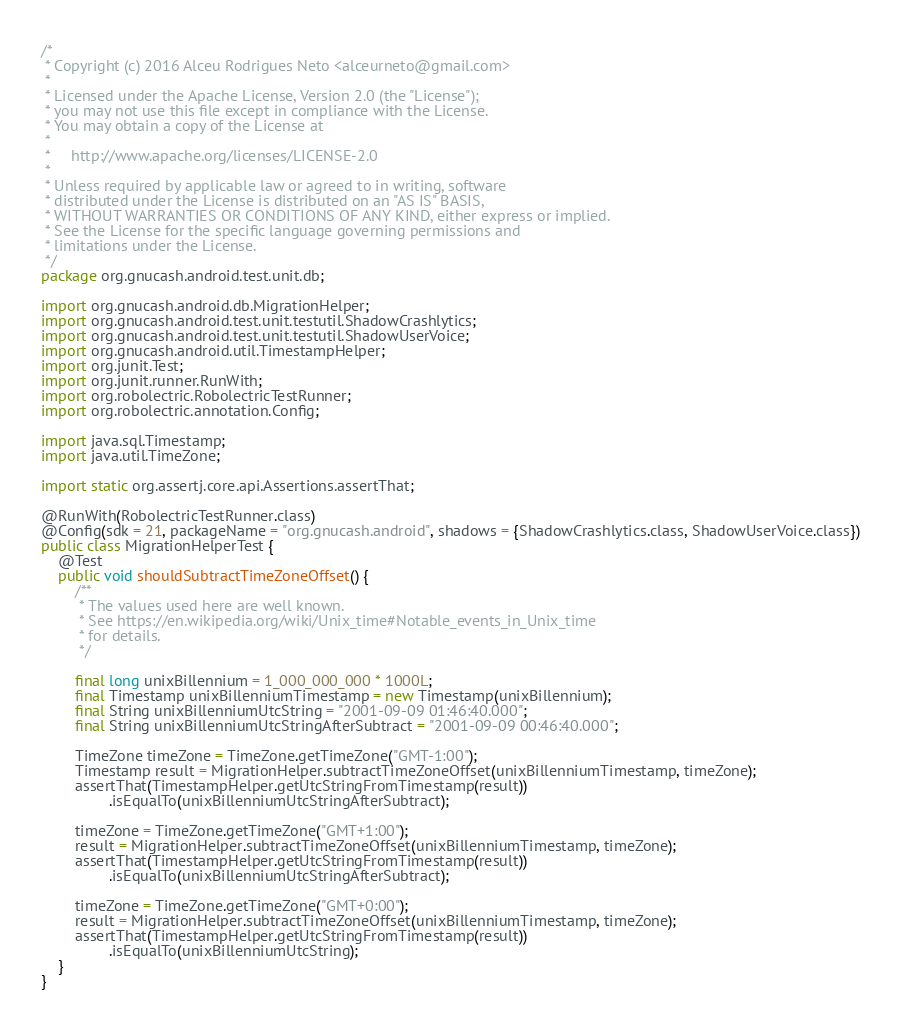Convert code to text. <code><loc_0><loc_0><loc_500><loc_500><_Java_>/*
 * Copyright (c) 2016 Alceu Rodrigues Neto <alceurneto@gmail.com>
 *
 * Licensed under the Apache License, Version 2.0 (the "License");
 * you may not use this file except in compliance with the License.
 * You may obtain a copy of the License at
 *
 *     http://www.apache.org/licenses/LICENSE-2.0
 *
 * Unless required by applicable law or agreed to in writing, software
 * distributed under the License is distributed on an "AS IS" BASIS,
 * WITHOUT WARRANTIES OR CONDITIONS OF ANY KIND, either express or implied.
 * See the License for the specific language governing permissions and
 * limitations under the License.
 */
package org.gnucash.android.test.unit.db;

import org.gnucash.android.db.MigrationHelper;
import org.gnucash.android.test.unit.testutil.ShadowCrashlytics;
import org.gnucash.android.test.unit.testutil.ShadowUserVoice;
import org.gnucash.android.util.TimestampHelper;
import org.junit.Test;
import org.junit.runner.RunWith;
import org.robolectric.RobolectricTestRunner;
import org.robolectric.annotation.Config;

import java.sql.Timestamp;
import java.util.TimeZone;

import static org.assertj.core.api.Assertions.assertThat;

@RunWith(RobolectricTestRunner.class)
@Config(sdk = 21, packageName = "org.gnucash.android", shadows = {ShadowCrashlytics.class, ShadowUserVoice.class})
public class MigrationHelperTest {
    @Test
    public void shouldSubtractTimeZoneOffset() {
        /**
         * The values used here are well known.
         * See https://en.wikipedia.org/wiki/Unix_time#Notable_events_in_Unix_time
         * for details.
         */

        final long unixBillennium = 1_000_000_000 * 1000L;
        final Timestamp unixBillenniumTimestamp = new Timestamp(unixBillennium);
        final String unixBillenniumUtcString = "2001-09-09 01:46:40.000";
        final String unixBillenniumUtcStringAfterSubtract = "2001-09-09 00:46:40.000";

        TimeZone timeZone = TimeZone.getTimeZone("GMT-1:00");
        Timestamp result = MigrationHelper.subtractTimeZoneOffset(unixBillenniumTimestamp, timeZone);
        assertThat(TimestampHelper.getUtcStringFromTimestamp(result))
                .isEqualTo(unixBillenniumUtcStringAfterSubtract);

        timeZone = TimeZone.getTimeZone("GMT+1:00");
        result = MigrationHelper.subtractTimeZoneOffset(unixBillenniumTimestamp, timeZone);
        assertThat(TimestampHelper.getUtcStringFromTimestamp(result))
                .isEqualTo(unixBillenniumUtcStringAfterSubtract);

        timeZone = TimeZone.getTimeZone("GMT+0:00");
        result = MigrationHelper.subtractTimeZoneOffset(unixBillenniumTimestamp, timeZone);
        assertThat(TimestampHelper.getUtcStringFromTimestamp(result))
                .isEqualTo(unixBillenniumUtcString);
    }
}</code> 